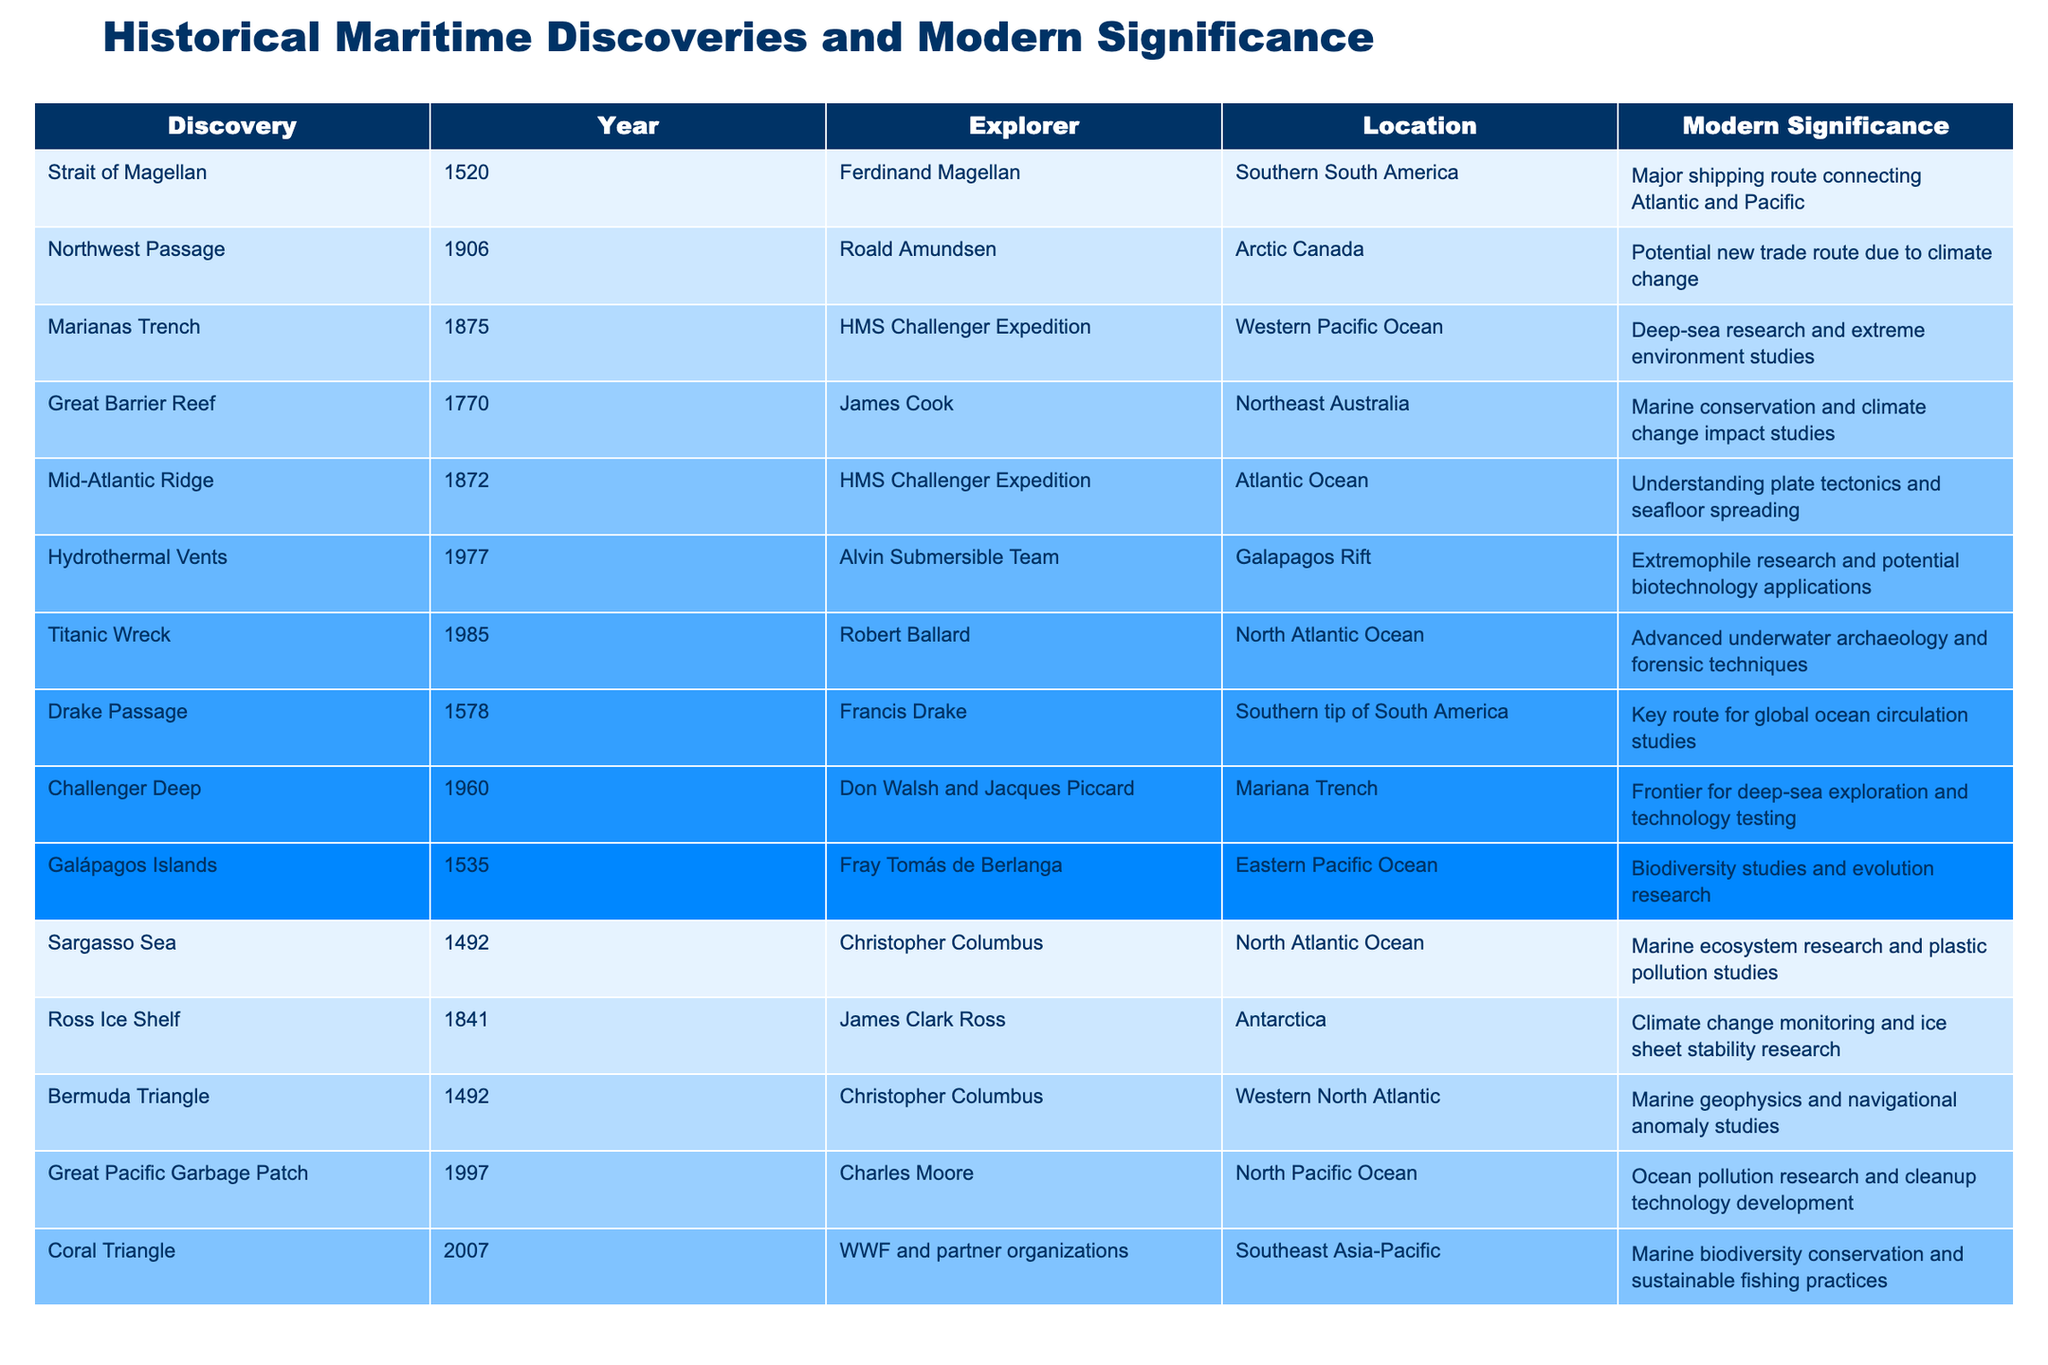What was the year of the discovery of the Great Barrier Reef? The table lists the year for each discovery alongside its name, and the Great Barrier Reef is noted as being discovered in 1770.
Answer: 1770 Who was the explorer associated with the Marianas Trench? According to the table, the Marianas Trench was discovered by the HMS Challenger Expedition, which is attributed to no single explorer but rather the team involved in that expedition.
Answer: HMS Challenger Expedition What modern significance is associated with the Northwest Passage? The table explicitly states that the modern significance of the Northwest Passage is its potential as a new trade route due to climate change.
Answer: Potential new trade route due to climate change How many discoveries were made before the 1800s? By counting the entries in the table, we see that there are nine discoveries listed with years prior to 1800 (before 1800: 1492, 1520, 1535, 1578, 1770, 1841, 1872, 1875). Thus, there are eight discoveries in total.
Answer: 8 Is the discovery of the Titanic Wreck associated with marine conservation? The table indicates the Titanic Wreck’s significance relates to advanced underwater archaeology and forensic techniques, not directly to marine conservation, so the answer is no.
Answer: No What is the relationship between the Drake Passage and global ocean circulation? From the table, we see that the Drake Passage is noted as a key route for global ocean circulation studies, which indicates an important relationship between the two.
Answer: Key route for global ocean circulation studies Which discovery has the most recent year of discovery? By examining the years listed in the table, the most recent year of discovery noted is 2007 for the Coral Triangle.
Answer: 2007 What is the total number of discoveries listed in the table? There are 14 entries in the table, which can be counted directly to arrive at this total.
Answer: 14 Which explorer discovered both the Sargasso Sea and the Bermuda Triangle? The table shows that both the Sargasso Sea and the Bermuda Triangle were discovered by Christopher Columbus in 1492.
Answer: Christopher Columbus What kind of research is conducted at the Hydrothermal Vents? The table mentions that Hydrothermal Vents are significant for extremophile research and potential biotechnology applications, indicating the type of research performed there.
Answer: Extremophile research and potential biotechnology applications 